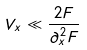<formula> <loc_0><loc_0><loc_500><loc_500>V _ { x } \ll \frac { 2 F } { \partial _ { x } ^ { 2 } F }</formula> 